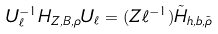<formula> <loc_0><loc_0><loc_500><loc_500>U _ { \ell } ^ { - 1 } H _ { Z , B , \rho } U _ { \ell } = ( Z \ell ^ { - 1 } ) \tilde { H } _ { h , b , \tilde { \rho } }</formula> 